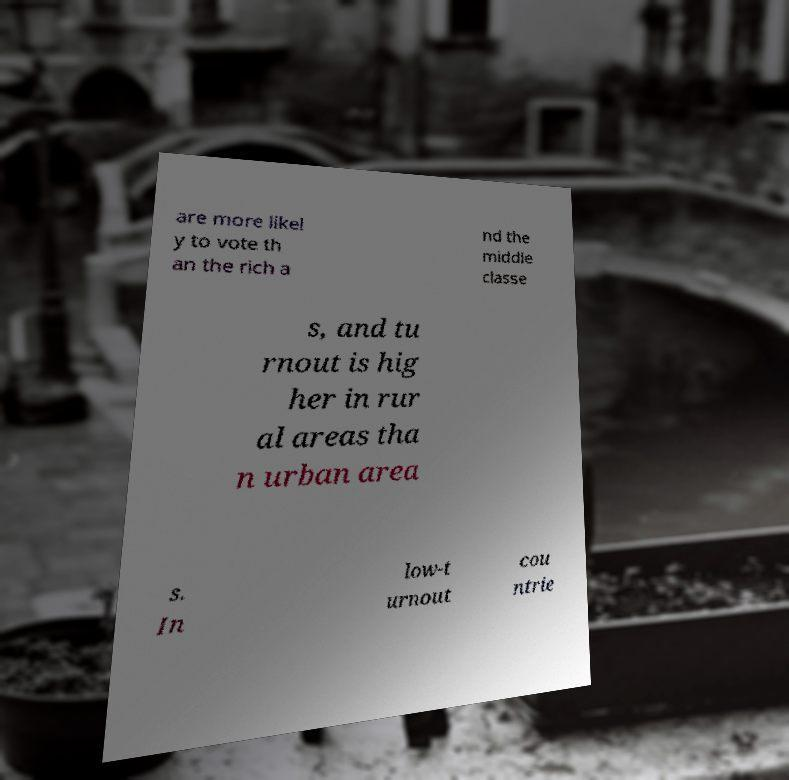What messages or text are displayed in this image? I need them in a readable, typed format. are more likel y to vote th an the rich a nd the middle classe s, and tu rnout is hig her in rur al areas tha n urban area s. In low-t urnout cou ntrie 